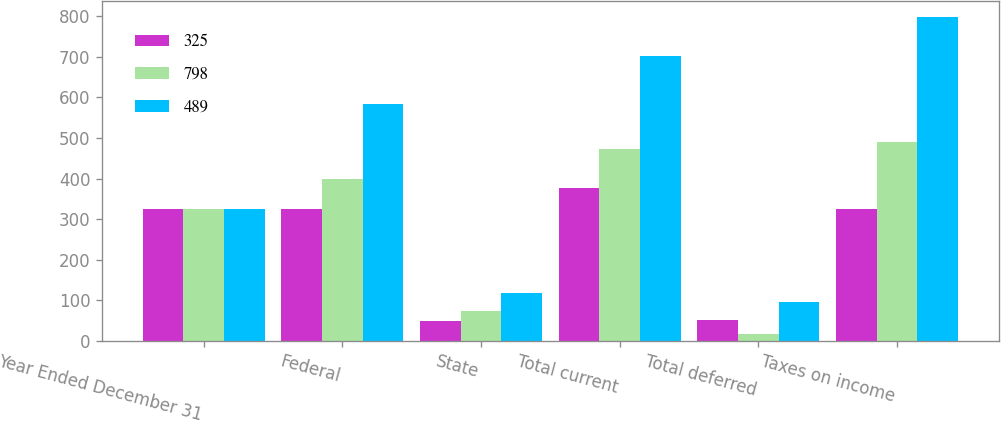Convert chart. <chart><loc_0><loc_0><loc_500><loc_500><stacked_bar_chart><ecel><fcel>Year Ended December 31<fcel>Federal<fcel>State<fcel>Total current<fcel>Total deferred<fcel>Taxes on income<nl><fcel>325<fcel>326<fcel>326<fcel>50<fcel>376<fcel>51<fcel>325<nl><fcel>798<fcel>326<fcel>400<fcel>73<fcel>473<fcel>16<fcel>489<nl><fcel>489<fcel>326<fcel>584<fcel>117<fcel>701<fcel>97<fcel>798<nl></chart> 